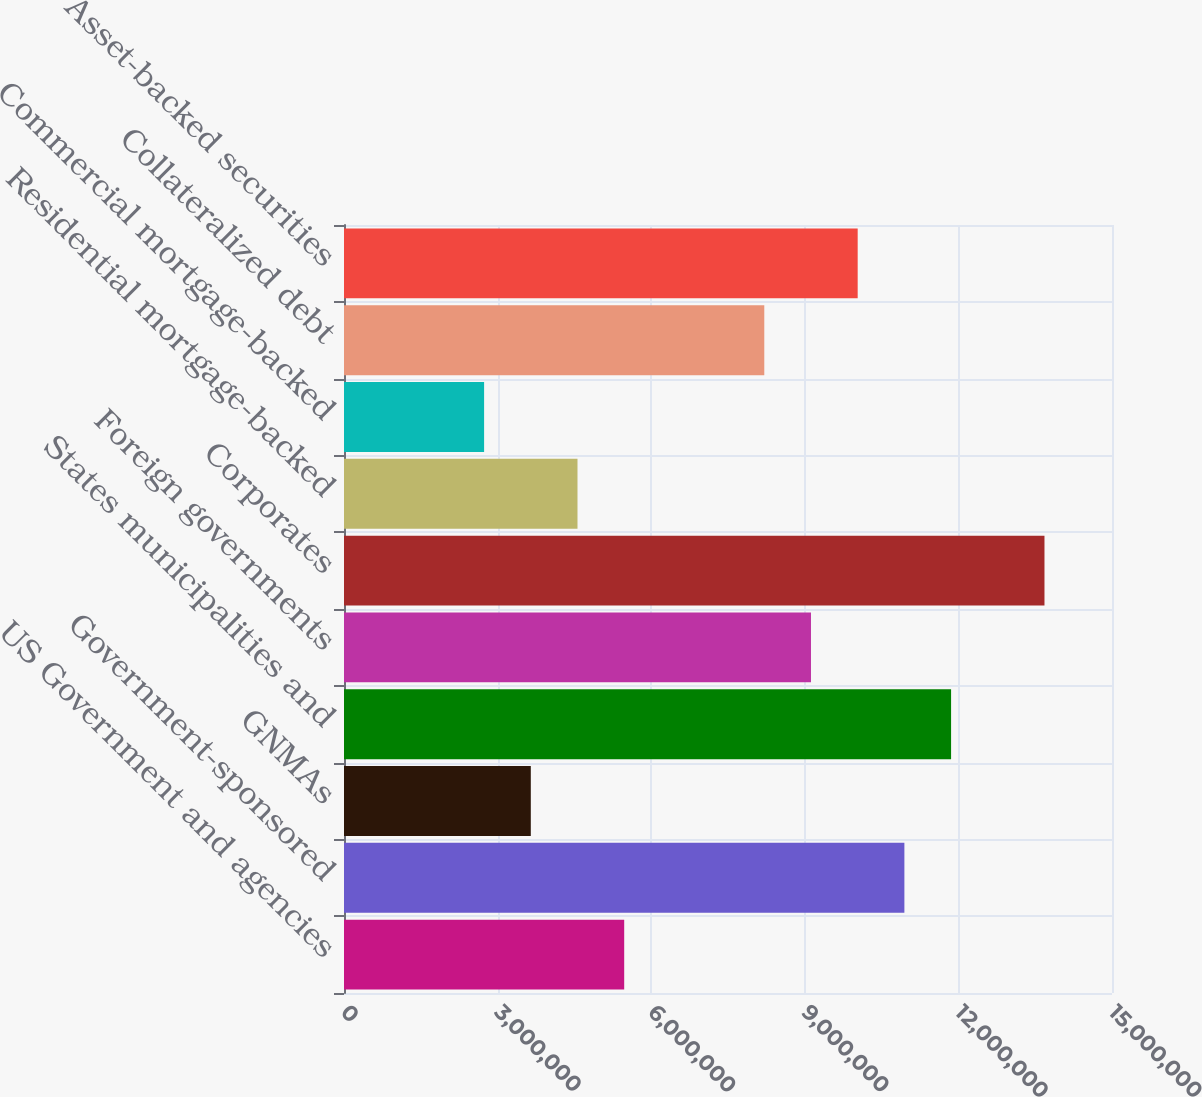<chart> <loc_0><loc_0><loc_500><loc_500><bar_chart><fcel>US Government and agencies<fcel>Government-sponsored<fcel>GNMAs<fcel>States municipalities and<fcel>Foreign governments<fcel>Corporates<fcel>Residential mortgage-backed<fcel>Commercial mortgage-backed<fcel>Collateralized debt<fcel>Asset-backed securities<nl><fcel>5.4725e+06<fcel>1.0945e+07<fcel>3.64834e+06<fcel>1.18571e+07<fcel>9.12084e+06<fcel>1.36813e+07<fcel>4.56042e+06<fcel>2.73625e+06<fcel>8.20875e+06<fcel>1.00329e+07<nl></chart> 